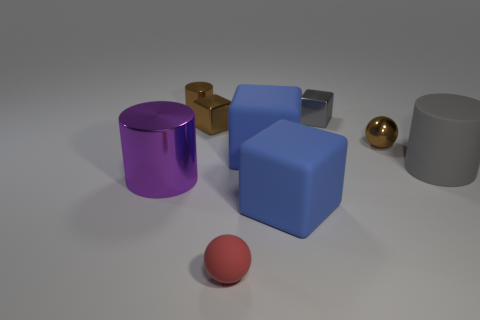Subtract all purple shiny cylinders. How many cylinders are left? 2 Subtract all purple cylinders. How many blue blocks are left? 2 Subtract 1 cubes. How many cubes are left? 3 Subtract all gray cubes. How many cubes are left? 3 Subtract all cylinders. How many objects are left? 6 Subtract all cyan cylinders. Subtract all red blocks. How many cylinders are left? 3 Subtract all tiny brown blocks. Subtract all blue balls. How many objects are left? 8 Add 2 small gray things. How many small gray things are left? 3 Add 2 metal balls. How many metal balls exist? 3 Subtract 0 green blocks. How many objects are left? 9 